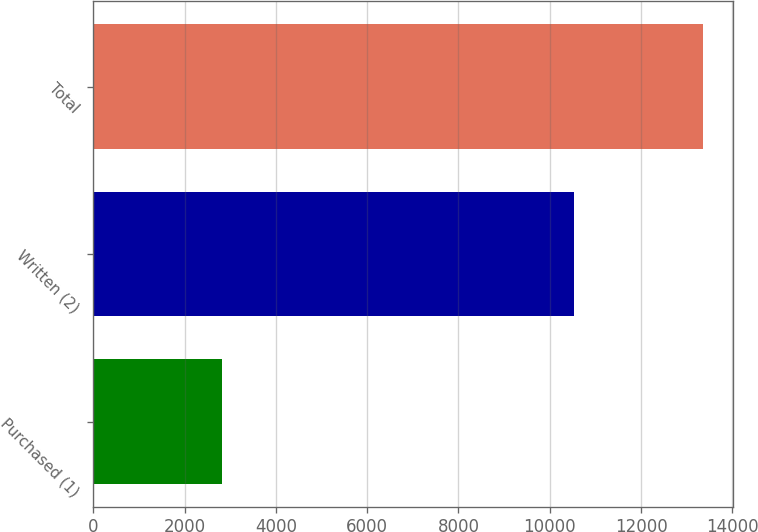<chart> <loc_0><loc_0><loc_500><loc_500><bar_chart><fcel>Purchased (1)<fcel>Written (2)<fcel>Total<nl><fcel>2830<fcel>10527<fcel>13357<nl></chart> 